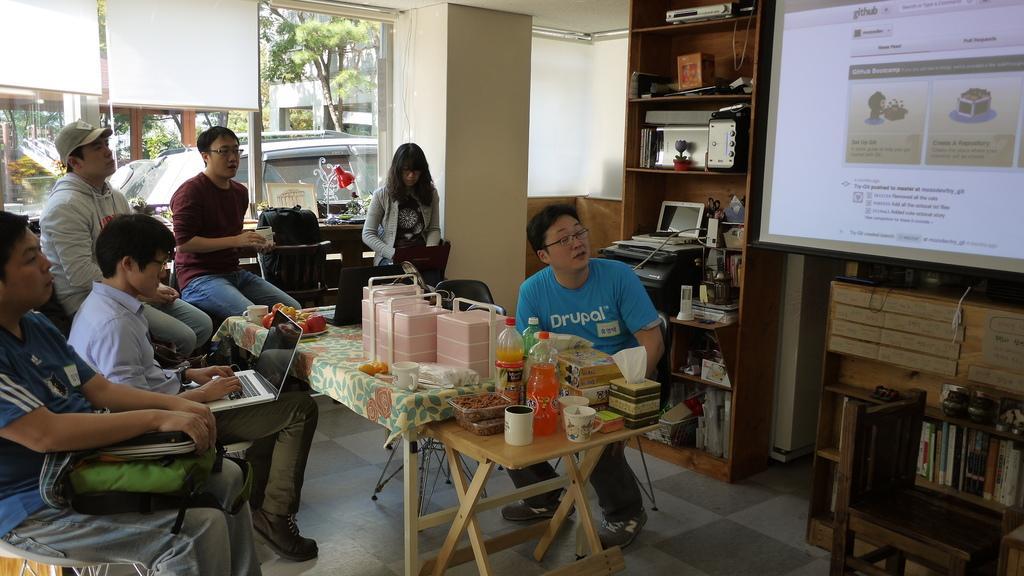Could you give a brief overview of what you see in this image? I can see in this image there are group of people who are sitting on the chair in front of a table. On the table we have few glass bottles, cups and other objects on it. I can also see there is a projector screen and a shelf with few objects in it. 